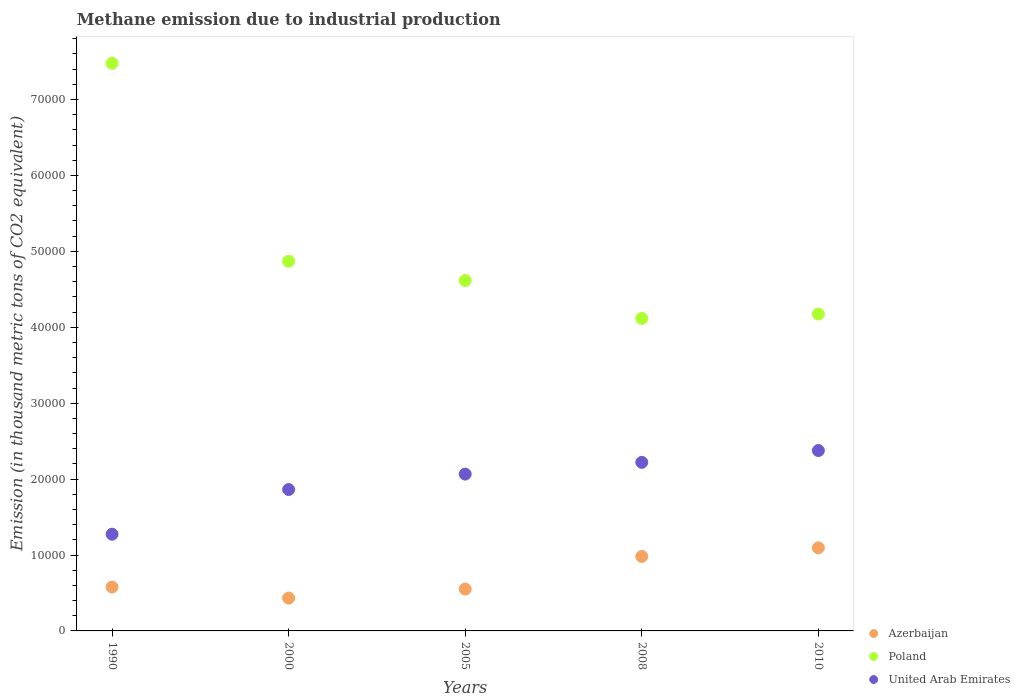Is the number of dotlines equal to the number of legend labels?
Make the answer very short. Yes. What is the amount of methane emitted in Azerbaijan in 1990?
Provide a succinct answer. 5773. Across all years, what is the maximum amount of methane emitted in United Arab Emirates?
Give a very brief answer. 2.38e+04. Across all years, what is the minimum amount of methane emitted in Azerbaijan?
Keep it short and to the point. 4327.8. In which year was the amount of methane emitted in Azerbaijan maximum?
Keep it short and to the point. 2010. What is the total amount of methane emitted in Azerbaijan in the graph?
Keep it short and to the point. 3.64e+04. What is the difference between the amount of methane emitted in United Arab Emirates in 1990 and that in 2010?
Provide a short and direct response. -1.10e+04. What is the difference between the amount of methane emitted in Azerbaijan in 2010 and the amount of methane emitted in Poland in 2008?
Provide a succinct answer. -3.02e+04. What is the average amount of methane emitted in United Arab Emirates per year?
Your response must be concise. 1.96e+04. In the year 2008, what is the difference between the amount of methane emitted in Poland and amount of methane emitted in United Arab Emirates?
Your answer should be compact. 1.90e+04. In how many years, is the amount of methane emitted in Poland greater than 32000 thousand metric tons?
Offer a terse response. 5. What is the ratio of the amount of methane emitted in Azerbaijan in 2005 to that in 2010?
Your response must be concise. 0.5. Is the amount of methane emitted in United Arab Emirates in 1990 less than that in 2005?
Keep it short and to the point. Yes. Is the difference between the amount of methane emitted in Poland in 2000 and 2005 greater than the difference between the amount of methane emitted in United Arab Emirates in 2000 and 2005?
Provide a succinct answer. Yes. What is the difference between the highest and the second highest amount of methane emitted in Azerbaijan?
Your answer should be very brief. 1129.7. What is the difference between the highest and the lowest amount of methane emitted in Azerbaijan?
Offer a very short reply. 6614.3. In how many years, is the amount of methane emitted in United Arab Emirates greater than the average amount of methane emitted in United Arab Emirates taken over all years?
Your response must be concise. 3. How many years are there in the graph?
Provide a short and direct response. 5. Does the graph contain any zero values?
Keep it short and to the point. No. Where does the legend appear in the graph?
Provide a short and direct response. Bottom right. What is the title of the graph?
Give a very brief answer. Methane emission due to industrial production. Does "Latvia" appear as one of the legend labels in the graph?
Make the answer very short. No. What is the label or title of the Y-axis?
Provide a short and direct response. Emission (in thousand metric tons of CO2 equivalent). What is the Emission (in thousand metric tons of CO2 equivalent) of Azerbaijan in 1990?
Provide a succinct answer. 5773. What is the Emission (in thousand metric tons of CO2 equivalent) of Poland in 1990?
Your response must be concise. 7.48e+04. What is the Emission (in thousand metric tons of CO2 equivalent) in United Arab Emirates in 1990?
Your answer should be very brief. 1.27e+04. What is the Emission (in thousand metric tons of CO2 equivalent) in Azerbaijan in 2000?
Ensure brevity in your answer.  4327.8. What is the Emission (in thousand metric tons of CO2 equivalent) in Poland in 2000?
Make the answer very short. 4.87e+04. What is the Emission (in thousand metric tons of CO2 equivalent) in United Arab Emirates in 2000?
Provide a short and direct response. 1.86e+04. What is the Emission (in thousand metric tons of CO2 equivalent) of Azerbaijan in 2005?
Offer a very short reply. 5515.2. What is the Emission (in thousand metric tons of CO2 equivalent) of Poland in 2005?
Your response must be concise. 4.62e+04. What is the Emission (in thousand metric tons of CO2 equivalent) in United Arab Emirates in 2005?
Provide a succinct answer. 2.07e+04. What is the Emission (in thousand metric tons of CO2 equivalent) of Azerbaijan in 2008?
Offer a very short reply. 9812.4. What is the Emission (in thousand metric tons of CO2 equivalent) in Poland in 2008?
Provide a short and direct response. 4.12e+04. What is the Emission (in thousand metric tons of CO2 equivalent) of United Arab Emirates in 2008?
Offer a very short reply. 2.22e+04. What is the Emission (in thousand metric tons of CO2 equivalent) of Azerbaijan in 2010?
Provide a short and direct response. 1.09e+04. What is the Emission (in thousand metric tons of CO2 equivalent) in Poland in 2010?
Offer a terse response. 4.17e+04. What is the Emission (in thousand metric tons of CO2 equivalent) in United Arab Emirates in 2010?
Make the answer very short. 2.38e+04. Across all years, what is the maximum Emission (in thousand metric tons of CO2 equivalent) of Azerbaijan?
Your answer should be very brief. 1.09e+04. Across all years, what is the maximum Emission (in thousand metric tons of CO2 equivalent) in Poland?
Your answer should be compact. 7.48e+04. Across all years, what is the maximum Emission (in thousand metric tons of CO2 equivalent) of United Arab Emirates?
Keep it short and to the point. 2.38e+04. Across all years, what is the minimum Emission (in thousand metric tons of CO2 equivalent) in Azerbaijan?
Your response must be concise. 4327.8. Across all years, what is the minimum Emission (in thousand metric tons of CO2 equivalent) of Poland?
Keep it short and to the point. 4.12e+04. Across all years, what is the minimum Emission (in thousand metric tons of CO2 equivalent) of United Arab Emirates?
Your answer should be compact. 1.27e+04. What is the total Emission (in thousand metric tons of CO2 equivalent) of Azerbaijan in the graph?
Offer a terse response. 3.64e+04. What is the total Emission (in thousand metric tons of CO2 equivalent) of Poland in the graph?
Give a very brief answer. 2.53e+05. What is the total Emission (in thousand metric tons of CO2 equivalent) in United Arab Emirates in the graph?
Provide a short and direct response. 9.80e+04. What is the difference between the Emission (in thousand metric tons of CO2 equivalent) of Azerbaijan in 1990 and that in 2000?
Offer a terse response. 1445.2. What is the difference between the Emission (in thousand metric tons of CO2 equivalent) in Poland in 1990 and that in 2000?
Your answer should be compact. 2.61e+04. What is the difference between the Emission (in thousand metric tons of CO2 equivalent) of United Arab Emirates in 1990 and that in 2000?
Ensure brevity in your answer.  -5885.7. What is the difference between the Emission (in thousand metric tons of CO2 equivalent) of Azerbaijan in 1990 and that in 2005?
Provide a succinct answer. 257.8. What is the difference between the Emission (in thousand metric tons of CO2 equivalent) of Poland in 1990 and that in 2005?
Make the answer very short. 2.86e+04. What is the difference between the Emission (in thousand metric tons of CO2 equivalent) of United Arab Emirates in 1990 and that in 2005?
Your answer should be very brief. -7915.3. What is the difference between the Emission (in thousand metric tons of CO2 equivalent) of Azerbaijan in 1990 and that in 2008?
Your answer should be compact. -4039.4. What is the difference between the Emission (in thousand metric tons of CO2 equivalent) in Poland in 1990 and that in 2008?
Keep it short and to the point. 3.36e+04. What is the difference between the Emission (in thousand metric tons of CO2 equivalent) of United Arab Emirates in 1990 and that in 2008?
Your answer should be very brief. -9464.3. What is the difference between the Emission (in thousand metric tons of CO2 equivalent) of Azerbaijan in 1990 and that in 2010?
Your response must be concise. -5169.1. What is the difference between the Emission (in thousand metric tons of CO2 equivalent) of Poland in 1990 and that in 2010?
Ensure brevity in your answer.  3.30e+04. What is the difference between the Emission (in thousand metric tons of CO2 equivalent) of United Arab Emirates in 1990 and that in 2010?
Offer a very short reply. -1.10e+04. What is the difference between the Emission (in thousand metric tons of CO2 equivalent) of Azerbaijan in 2000 and that in 2005?
Provide a succinct answer. -1187.4. What is the difference between the Emission (in thousand metric tons of CO2 equivalent) of Poland in 2000 and that in 2005?
Keep it short and to the point. 2536.5. What is the difference between the Emission (in thousand metric tons of CO2 equivalent) of United Arab Emirates in 2000 and that in 2005?
Your answer should be compact. -2029.6. What is the difference between the Emission (in thousand metric tons of CO2 equivalent) in Azerbaijan in 2000 and that in 2008?
Your response must be concise. -5484.6. What is the difference between the Emission (in thousand metric tons of CO2 equivalent) of Poland in 2000 and that in 2008?
Offer a terse response. 7532.6. What is the difference between the Emission (in thousand metric tons of CO2 equivalent) in United Arab Emirates in 2000 and that in 2008?
Provide a succinct answer. -3578.6. What is the difference between the Emission (in thousand metric tons of CO2 equivalent) of Azerbaijan in 2000 and that in 2010?
Give a very brief answer. -6614.3. What is the difference between the Emission (in thousand metric tons of CO2 equivalent) in Poland in 2000 and that in 2010?
Your response must be concise. 6963.4. What is the difference between the Emission (in thousand metric tons of CO2 equivalent) in United Arab Emirates in 2000 and that in 2010?
Ensure brevity in your answer.  -5132.6. What is the difference between the Emission (in thousand metric tons of CO2 equivalent) of Azerbaijan in 2005 and that in 2008?
Your response must be concise. -4297.2. What is the difference between the Emission (in thousand metric tons of CO2 equivalent) of Poland in 2005 and that in 2008?
Your answer should be very brief. 4996.1. What is the difference between the Emission (in thousand metric tons of CO2 equivalent) of United Arab Emirates in 2005 and that in 2008?
Ensure brevity in your answer.  -1549. What is the difference between the Emission (in thousand metric tons of CO2 equivalent) in Azerbaijan in 2005 and that in 2010?
Keep it short and to the point. -5426.9. What is the difference between the Emission (in thousand metric tons of CO2 equivalent) of Poland in 2005 and that in 2010?
Provide a succinct answer. 4426.9. What is the difference between the Emission (in thousand metric tons of CO2 equivalent) in United Arab Emirates in 2005 and that in 2010?
Provide a short and direct response. -3103. What is the difference between the Emission (in thousand metric tons of CO2 equivalent) of Azerbaijan in 2008 and that in 2010?
Your answer should be very brief. -1129.7. What is the difference between the Emission (in thousand metric tons of CO2 equivalent) in Poland in 2008 and that in 2010?
Provide a succinct answer. -569.2. What is the difference between the Emission (in thousand metric tons of CO2 equivalent) of United Arab Emirates in 2008 and that in 2010?
Your response must be concise. -1554. What is the difference between the Emission (in thousand metric tons of CO2 equivalent) of Azerbaijan in 1990 and the Emission (in thousand metric tons of CO2 equivalent) of Poland in 2000?
Make the answer very short. -4.29e+04. What is the difference between the Emission (in thousand metric tons of CO2 equivalent) of Azerbaijan in 1990 and the Emission (in thousand metric tons of CO2 equivalent) of United Arab Emirates in 2000?
Keep it short and to the point. -1.29e+04. What is the difference between the Emission (in thousand metric tons of CO2 equivalent) of Poland in 1990 and the Emission (in thousand metric tons of CO2 equivalent) of United Arab Emirates in 2000?
Provide a succinct answer. 5.61e+04. What is the difference between the Emission (in thousand metric tons of CO2 equivalent) of Azerbaijan in 1990 and the Emission (in thousand metric tons of CO2 equivalent) of Poland in 2005?
Offer a terse response. -4.04e+04. What is the difference between the Emission (in thousand metric tons of CO2 equivalent) in Azerbaijan in 1990 and the Emission (in thousand metric tons of CO2 equivalent) in United Arab Emirates in 2005?
Offer a very short reply. -1.49e+04. What is the difference between the Emission (in thousand metric tons of CO2 equivalent) in Poland in 1990 and the Emission (in thousand metric tons of CO2 equivalent) in United Arab Emirates in 2005?
Offer a terse response. 5.41e+04. What is the difference between the Emission (in thousand metric tons of CO2 equivalent) in Azerbaijan in 1990 and the Emission (in thousand metric tons of CO2 equivalent) in Poland in 2008?
Ensure brevity in your answer.  -3.54e+04. What is the difference between the Emission (in thousand metric tons of CO2 equivalent) of Azerbaijan in 1990 and the Emission (in thousand metric tons of CO2 equivalent) of United Arab Emirates in 2008?
Your answer should be compact. -1.64e+04. What is the difference between the Emission (in thousand metric tons of CO2 equivalent) of Poland in 1990 and the Emission (in thousand metric tons of CO2 equivalent) of United Arab Emirates in 2008?
Your answer should be compact. 5.26e+04. What is the difference between the Emission (in thousand metric tons of CO2 equivalent) of Azerbaijan in 1990 and the Emission (in thousand metric tons of CO2 equivalent) of Poland in 2010?
Provide a short and direct response. -3.60e+04. What is the difference between the Emission (in thousand metric tons of CO2 equivalent) in Azerbaijan in 1990 and the Emission (in thousand metric tons of CO2 equivalent) in United Arab Emirates in 2010?
Ensure brevity in your answer.  -1.80e+04. What is the difference between the Emission (in thousand metric tons of CO2 equivalent) of Poland in 1990 and the Emission (in thousand metric tons of CO2 equivalent) of United Arab Emirates in 2010?
Your response must be concise. 5.10e+04. What is the difference between the Emission (in thousand metric tons of CO2 equivalent) in Azerbaijan in 2000 and the Emission (in thousand metric tons of CO2 equivalent) in Poland in 2005?
Offer a very short reply. -4.18e+04. What is the difference between the Emission (in thousand metric tons of CO2 equivalent) of Azerbaijan in 2000 and the Emission (in thousand metric tons of CO2 equivalent) of United Arab Emirates in 2005?
Provide a succinct answer. -1.63e+04. What is the difference between the Emission (in thousand metric tons of CO2 equivalent) in Poland in 2000 and the Emission (in thousand metric tons of CO2 equivalent) in United Arab Emirates in 2005?
Provide a short and direct response. 2.80e+04. What is the difference between the Emission (in thousand metric tons of CO2 equivalent) of Azerbaijan in 2000 and the Emission (in thousand metric tons of CO2 equivalent) of Poland in 2008?
Your response must be concise. -3.68e+04. What is the difference between the Emission (in thousand metric tons of CO2 equivalent) in Azerbaijan in 2000 and the Emission (in thousand metric tons of CO2 equivalent) in United Arab Emirates in 2008?
Make the answer very short. -1.79e+04. What is the difference between the Emission (in thousand metric tons of CO2 equivalent) in Poland in 2000 and the Emission (in thousand metric tons of CO2 equivalent) in United Arab Emirates in 2008?
Give a very brief answer. 2.65e+04. What is the difference between the Emission (in thousand metric tons of CO2 equivalent) of Azerbaijan in 2000 and the Emission (in thousand metric tons of CO2 equivalent) of Poland in 2010?
Keep it short and to the point. -3.74e+04. What is the difference between the Emission (in thousand metric tons of CO2 equivalent) in Azerbaijan in 2000 and the Emission (in thousand metric tons of CO2 equivalent) in United Arab Emirates in 2010?
Your answer should be very brief. -1.94e+04. What is the difference between the Emission (in thousand metric tons of CO2 equivalent) of Poland in 2000 and the Emission (in thousand metric tons of CO2 equivalent) of United Arab Emirates in 2010?
Your answer should be compact. 2.49e+04. What is the difference between the Emission (in thousand metric tons of CO2 equivalent) of Azerbaijan in 2005 and the Emission (in thousand metric tons of CO2 equivalent) of Poland in 2008?
Keep it short and to the point. -3.57e+04. What is the difference between the Emission (in thousand metric tons of CO2 equivalent) in Azerbaijan in 2005 and the Emission (in thousand metric tons of CO2 equivalent) in United Arab Emirates in 2008?
Provide a short and direct response. -1.67e+04. What is the difference between the Emission (in thousand metric tons of CO2 equivalent) in Poland in 2005 and the Emission (in thousand metric tons of CO2 equivalent) in United Arab Emirates in 2008?
Keep it short and to the point. 2.40e+04. What is the difference between the Emission (in thousand metric tons of CO2 equivalent) of Azerbaijan in 2005 and the Emission (in thousand metric tons of CO2 equivalent) of Poland in 2010?
Offer a very short reply. -3.62e+04. What is the difference between the Emission (in thousand metric tons of CO2 equivalent) of Azerbaijan in 2005 and the Emission (in thousand metric tons of CO2 equivalent) of United Arab Emirates in 2010?
Provide a succinct answer. -1.82e+04. What is the difference between the Emission (in thousand metric tons of CO2 equivalent) in Poland in 2005 and the Emission (in thousand metric tons of CO2 equivalent) in United Arab Emirates in 2010?
Keep it short and to the point. 2.24e+04. What is the difference between the Emission (in thousand metric tons of CO2 equivalent) in Azerbaijan in 2008 and the Emission (in thousand metric tons of CO2 equivalent) in Poland in 2010?
Provide a succinct answer. -3.19e+04. What is the difference between the Emission (in thousand metric tons of CO2 equivalent) in Azerbaijan in 2008 and the Emission (in thousand metric tons of CO2 equivalent) in United Arab Emirates in 2010?
Make the answer very short. -1.39e+04. What is the difference between the Emission (in thousand metric tons of CO2 equivalent) of Poland in 2008 and the Emission (in thousand metric tons of CO2 equivalent) of United Arab Emirates in 2010?
Make the answer very short. 1.74e+04. What is the average Emission (in thousand metric tons of CO2 equivalent) of Azerbaijan per year?
Ensure brevity in your answer.  7274.1. What is the average Emission (in thousand metric tons of CO2 equivalent) of Poland per year?
Your answer should be very brief. 5.05e+04. What is the average Emission (in thousand metric tons of CO2 equivalent) in United Arab Emirates per year?
Your answer should be very brief. 1.96e+04. In the year 1990, what is the difference between the Emission (in thousand metric tons of CO2 equivalent) of Azerbaijan and Emission (in thousand metric tons of CO2 equivalent) of Poland?
Make the answer very short. -6.90e+04. In the year 1990, what is the difference between the Emission (in thousand metric tons of CO2 equivalent) of Azerbaijan and Emission (in thousand metric tons of CO2 equivalent) of United Arab Emirates?
Provide a short and direct response. -6968. In the year 1990, what is the difference between the Emission (in thousand metric tons of CO2 equivalent) in Poland and Emission (in thousand metric tons of CO2 equivalent) in United Arab Emirates?
Your answer should be very brief. 6.20e+04. In the year 2000, what is the difference between the Emission (in thousand metric tons of CO2 equivalent) in Azerbaijan and Emission (in thousand metric tons of CO2 equivalent) in Poland?
Give a very brief answer. -4.44e+04. In the year 2000, what is the difference between the Emission (in thousand metric tons of CO2 equivalent) of Azerbaijan and Emission (in thousand metric tons of CO2 equivalent) of United Arab Emirates?
Give a very brief answer. -1.43e+04. In the year 2000, what is the difference between the Emission (in thousand metric tons of CO2 equivalent) of Poland and Emission (in thousand metric tons of CO2 equivalent) of United Arab Emirates?
Your answer should be compact. 3.01e+04. In the year 2005, what is the difference between the Emission (in thousand metric tons of CO2 equivalent) of Azerbaijan and Emission (in thousand metric tons of CO2 equivalent) of Poland?
Your answer should be very brief. -4.06e+04. In the year 2005, what is the difference between the Emission (in thousand metric tons of CO2 equivalent) in Azerbaijan and Emission (in thousand metric tons of CO2 equivalent) in United Arab Emirates?
Ensure brevity in your answer.  -1.51e+04. In the year 2005, what is the difference between the Emission (in thousand metric tons of CO2 equivalent) in Poland and Emission (in thousand metric tons of CO2 equivalent) in United Arab Emirates?
Your answer should be very brief. 2.55e+04. In the year 2008, what is the difference between the Emission (in thousand metric tons of CO2 equivalent) of Azerbaijan and Emission (in thousand metric tons of CO2 equivalent) of Poland?
Give a very brief answer. -3.14e+04. In the year 2008, what is the difference between the Emission (in thousand metric tons of CO2 equivalent) in Azerbaijan and Emission (in thousand metric tons of CO2 equivalent) in United Arab Emirates?
Your response must be concise. -1.24e+04. In the year 2008, what is the difference between the Emission (in thousand metric tons of CO2 equivalent) of Poland and Emission (in thousand metric tons of CO2 equivalent) of United Arab Emirates?
Your answer should be compact. 1.90e+04. In the year 2010, what is the difference between the Emission (in thousand metric tons of CO2 equivalent) in Azerbaijan and Emission (in thousand metric tons of CO2 equivalent) in Poland?
Provide a succinct answer. -3.08e+04. In the year 2010, what is the difference between the Emission (in thousand metric tons of CO2 equivalent) in Azerbaijan and Emission (in thousand metric tons of CO2 equivalent) in United Arab Emirates?
Ensure brevity in your answer.  -1.28e+04. In the year 2010, what is the difference between the Emission (in thousand metric tons of CO2 equivalent) in Poland and Emission (in thousand metric tons of CO2 equivalent) in United Arab Emirates?
Ensure brevity in your answer.  1.80e+04. What is the ratio of the Emission (in thousand metric tons of CO2 equivalent) in Azerbaijan in 1990 to that in 2000?
Offer a terse response. 1.33. What is the ratio of the Emission (in thousand metric tons of CO2 equivalent) of Poland in 1990 to that in 2000?
Keep it short and to the point. 1.54. What is the ratio of the Emission (in thousand metric tons of CO2 equivalent) in United Arab Emirates in 1990 to that in 2000?
Your answer should be compact. 0.68. What is the ratio of the Emission (in thousand metric tons of CO2 equivalent) in Azerbaijan in 1990 to that in 2005?
Give a very brief answer. 1.05. What is the ratio of the Emission (in thousand metric tons of CO2 equivalent) of Poland in 1990 to that in 2005?
Provide a short and direct response. 1.62. What is the ratio of the Emission (in thousand metric tons of CO2 equivalent) in United Arab Emirates in 1990 to that in 2005?
Ensure brevity in your answer.  0.62. What is the ratio of the Emission (in thousand metric tons of CO2 equivalent) of Azerbaijan in 1990 to that in 2008?
Your answer should be compact. 0.59. What is the ratio of the Emission (in thousand metric tons of CO2 equivalent) of Poland in 1990 to that in 2008?
Keep it short and to the point. 1.82. What is the ratio of the Emission (in thousand metric tons of CO2 equivalent) in United Arab Emirates in 1990 to that in 2008?
Give a very brief answer. 0.57. What is the ratio of the Emission (in thousand metric tons of CO2 equivalent) of Azerbaijan in 1990 to that in 2010?
Provide a short and direct response. 0.53. What is the ratio of the Emission (in thousand metric tons of CO2 equivalent) of Poland in 1990 to that in 2010?
Offer a terse response. 1.79. What is the ratio of the Emission (in thousand metric tons of CO2 equivalent) in United Arab Emirates in 1990 to that in 2010?
Offer a very short reply. 0.54. What is the ratio of the Emission (in thousand metric tons of CO2 equivalent) of Azerbaijan in 2000 to that in 2005?
Provide a short and direct response. 0.78. What is the ratio of the Emission (in thousand metric tons of CO2 equivalent) of Poland in 2000 to that in 2005?
Ensure brevity in your answer.  1.05. What is the ratio of the Emission (in thousand metric tons of CO2 equivalent) of United Arab Emirates in 2000 to that in 2005?
Your response must be concise. 0.9. What is the ratio of the Emission (in thousand metric tons of CO2 equivalent) in Azerbaijan in 2000 to that in 2008?
Ensure brevity in your answer.  0.44. What is the ratio of the Emission (in thousand metric tons of CO2 equivalent) in Poland in 2000 to that in 2008?
Your answer should be very brief. 1.18. What is the ratio of the Emission (in thousand metric tons of CO2 equivalent) of United Arab Emirates in 2000 to that in 2008?
Provide a short and direct response. 0.84. What is the ratio of the Emission (in thousand metric tons of CO2 equivalent) of Azerbaijan in 2000 to that in 2010?
Your answer should be very brief. 0.4. What is the ratio of the Emission (in thousand metric tons of CO2 equivalent) in Poland in 2000 to that in 2010?
Make the answer very short. 1.17. What is the ratio of the Emission (in thousand metric tons of CO2 equivalent) in United Arab Emirates in 2000 to that in 2010?
Keep it short and to the point. 0.78. What is the ratio of the Emission (in thousand metric tons of CO2 equivalent) of Azerbaijan in 2005 to that in 2008?
Make the answer very short. 0.56. What is the ratio of the Emission (in thousand metric tons of CO2 equivalent) in Poland in 2005 to that in 2008?
Ensure brevity in your answer.  1.12. What is the ratio of the Emission (in thousand metric tons of CO2 equivalent) of United Arab Emirates in 2005 to that in 2008?
Offer a very short reply. 0.93. What is the ratio of the Emission (in thousand metric tons of CO2 equivalent) in Azerbaijan in 2005 to that in 2010?
Your answer should be very brief. 0.5. What is the ratio of the Emission (in thousand metric tons of CO2 equivalent) in Poland in 2005 to that in 2010?
Give a very brief answer. 1.11. What is the ratio of the Emission (in thousand metric tons of CO2 equivalent) in United Arab Emirates in 2005 to that in 2010?
Your answer should be compact. 0.87. What is the ratio of the Emission (in thousand metric tons of CO2 equivalent) of Azerbaijan in 2008 to that in 2010?
Offer a very short reply. 0.9. What is the ratio of the Emission (in thousand metric tons of CO2 equivalent) in Poland in 2008 to that in 2010?
Give a very brief answer. 0.99. What is the ratio of the Emission (in thousand metric tons of CO2 equivalent) of United Arab Emirates in 2008 to that in 2010?
Provide a succinct answer. 0.93. What is the difference between the highest and the second highest Emission (in thousand metric tons of CO2 equivalent) of Azerbaijan?
Your answer should be very brief. 1129.7. What is the difference between the highest and the second highest Emission (in thousand metric tons of CO2 equivalent) of Poland?
Provide a short and direct response. 2.61e+04. What is the difference between the highest and the second highest Emission (in thousand metric tons of CO2 equivalent) in United Arab Emirates?
Provide a succinct answer. 1554. What is the difference between the highest and the lowest Emission (in thousand metric tons of CO2 equivalent) of Azerbaijan?
Keep it short and to the point. 6614.3. What is the difference between the highest and the lowest Emission (in thousand metric tons of CO2 equivalent) in Poland?
Your response must be concise. 3.36e+04. What is the difference between the highest and the lowest Emission (in thousand metric tons of CO2 equivalent) of United Arab Emirates?
Give a very brief answer. 1.10e+04. 